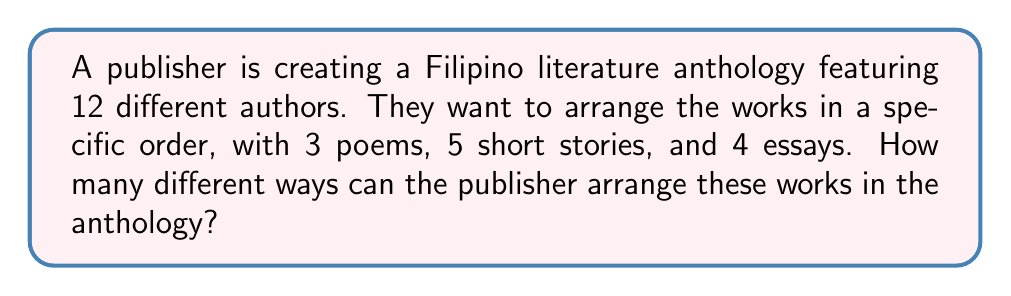Give your solution to this math problem. Let's approach this step-by-step:

1) First, we need to understand that this is a permutation problem. We're arranging all 12 works in a specific order.

2) However, this is not a simple permutation of 12 items. We need to consider the different types of works (poems, short stories, and essays) as distinct groups.

3) This scenario calls for the multiplication principle of counting.

4) We can break this down into three parts:
   a) Arranging the 3 poems among themselves
   b) Arranging the 5 short stories among themselves
   c) Arranging the 4 essays among themselves

5) For each part:
   a) The number of ways to arrange 3 poems: $3! = 3 \times 2 \times 1 = 6$
   b) The number of ways to arrange 5 short stories: $5! = 5 \times 4 \times 3 \times 2 \times 1 = 120$
   c) The number of ways to arrange 4 essays: $4! = 4 \times 3 \times 2 \times 1 = 24$

6) Now, we need to consider how many ways we can arrange these three groups (poems, short stories, essays) among themselves. This is a permutation of 3 items, which is $3! = 6$.

7) According to the multiplication principle, we multiply all these numbers together:

   $$ 6 \times 120 \times 24 \times 6 = 103,680 $$

Therefore, there are 103,680 different ways to arrange the works in the anthology.
Answer: 103,680 